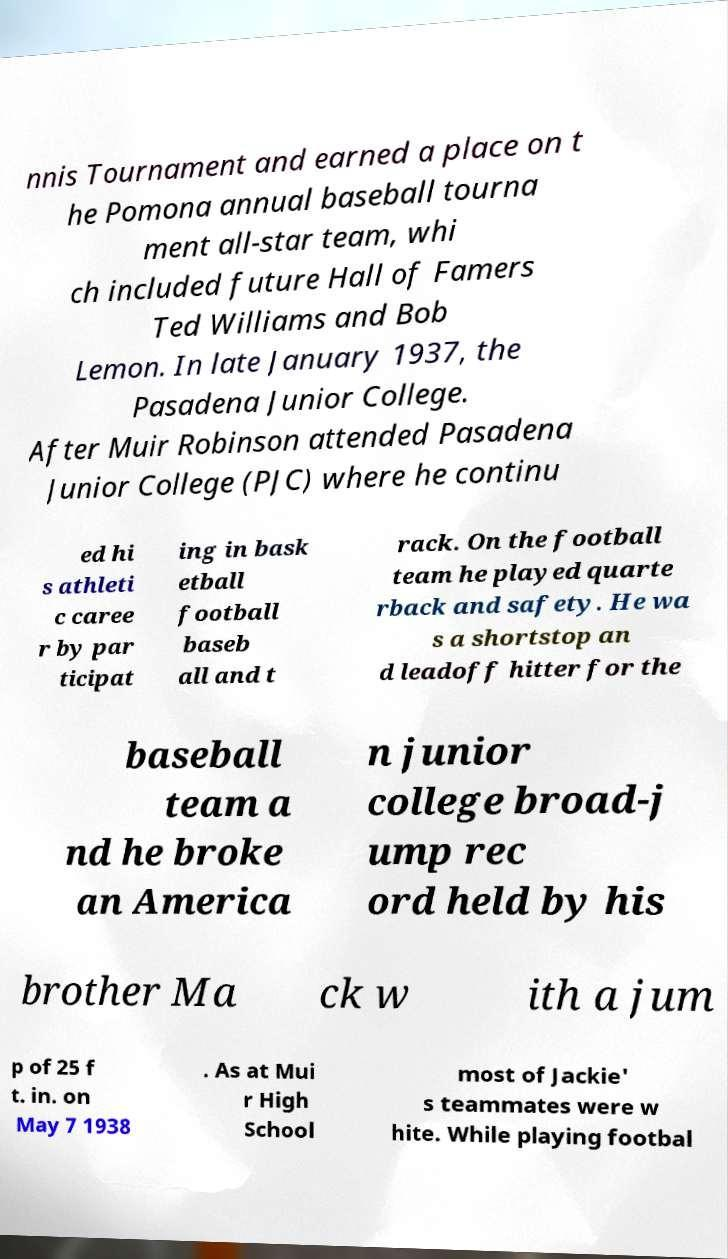There's text embedded in this image that I need extracted. Can you transcribe it verbatim? nnis Tournament and earned a place on t he Pomona annual baseball tourna ment all-star team, whi ch included future Hall of Famers Ted Williams and Bob Lemon. In late January 1937, the Pasadena Junior College. After Muir Robinson attended Pasadena Junior College (PJC) where he continu ed hi s athleti c caree r by par ticipat ing in bask etball football baseb all and t rack. On the football team he played quarte rback and safety. He wa s a shortstop an d leadoff hitter for the baseball team a nd he broke an America n junior college broad-j ump rec ord held by his brother Ma ck w ith a jum p of 25 f t. in. on May 7 1938 . As at Mui r High School most of Jackie' s teammates were w hite. While playing footbal 